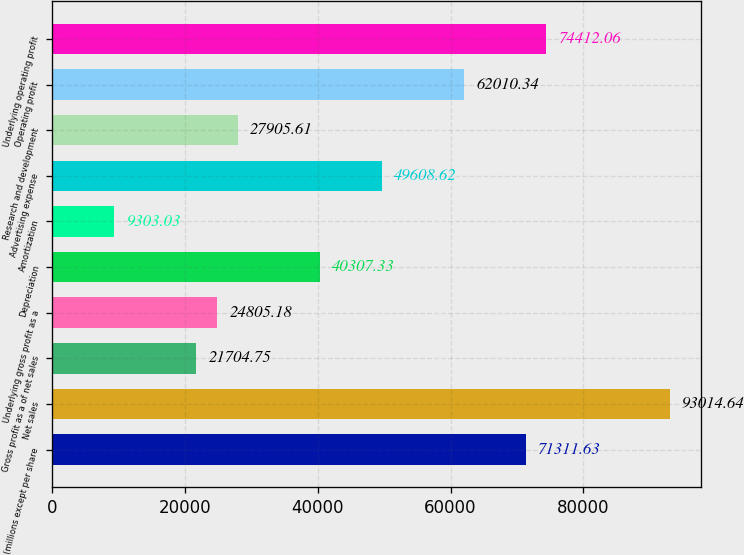Convert chart. <chart><loc_0><loc_0><loc_500><loc_500><bar_chart><fcel>(millions except per share<fcel>Net sales<fcel>Gross profit as a of net sales<fcel>Underlying gross profit as a<fcel>Depreciation<fcel>Amortization<fcel>Advertising expense<fcel>Research and development<fcel>Operating profit<fcel>Underlying operating profit<nl><fcel>71311.6<fcel>93014.6<fcel>21704.8<fcel>24805.2<fcel>40307.3<fcel>9303.03<fcel>49608.6<fcel>27905.6<fcel>62010.3<fcel>74412.1<nl></chart> 